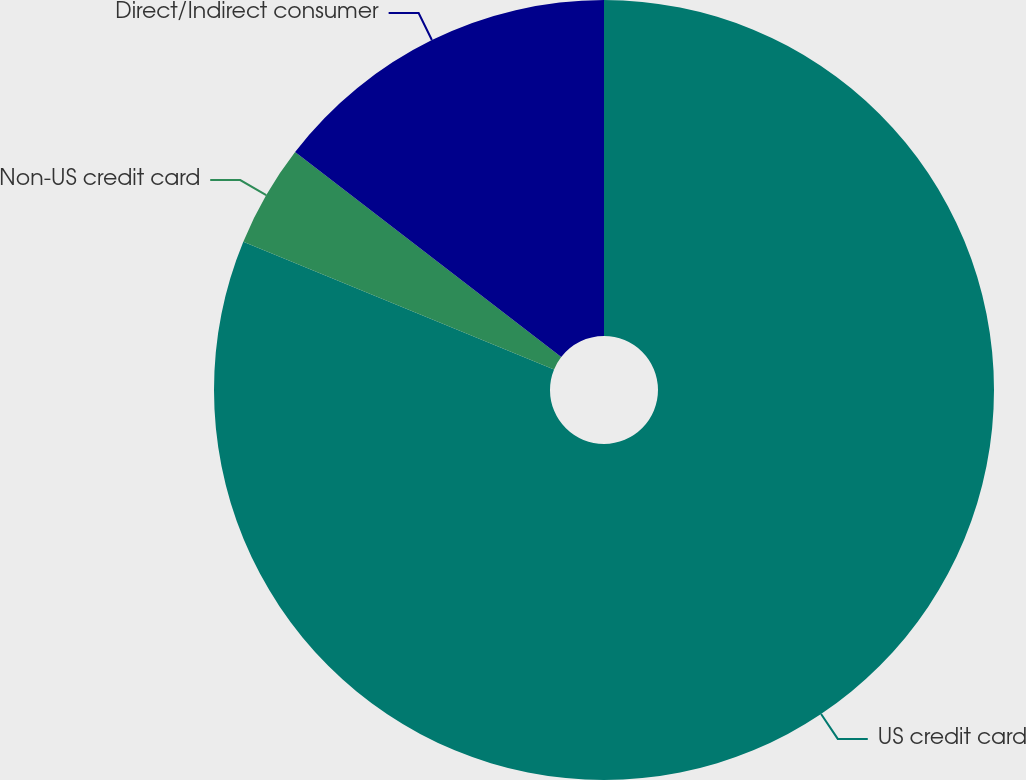Convert chart to OTSL. <chart><loc_0><loc_0><loc_500><loc_500><pie_chart><fcel>US credit card<fcel>Non-US credit card<fcel>Direct/Indirect consumer<nl><fcel>81.21%<fcel>4.24%<fcel>14.55%<nl></chart> 